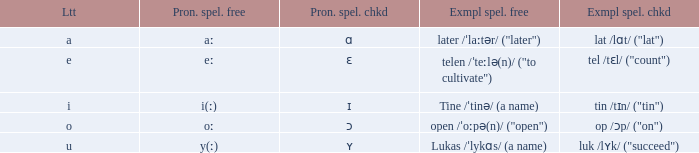What is Letter, when Example Spelled Checked is "tin /tɪn/ ("tin")"? I. 